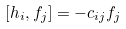<formula> <loc_0><loc_0><loc_500><loc_500>[ h _ { i } , f _ { j } ] = - c _ { i j } f _ { j }</formula> 